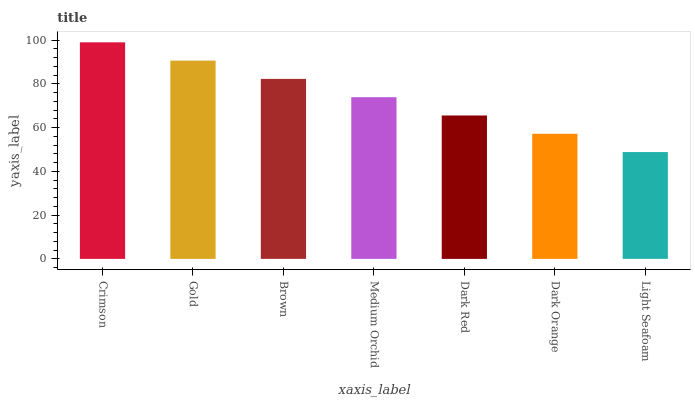Is Light Seafoam the minimum?
Answer yes or no. Yes. Is Crimson the maximum?
Answer yes or no. Yes. Is Gold the minimum?
Answer yes or no. No. Is Gold the maximum?
Answer yes or no. No. Is Crimson greater than Gold?
Answer yes or no. Yes. Is Gold less than Crimson?
Answer yes or no. Yes. Is Gold greater than Crimson?
Answer yes or no. No. Is Crimson less than Gold?
Answer yes or no. No. Is Medium Orchid the high median?
Answer yes or no. Yes. Is Medium Orchid the low median?
Answer yes or no. Yes. Is Dark Red the high median?
Answer yes or no. No. Is Dark Orange the low median?
Answer yes or no. No. 